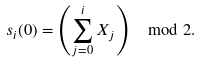Convert formula to latex. <formula><loc_0><loc_0><loc_500><loc_500>s _ { i } ( 0 ) = \left ( \sum _ { j = 0 } ^ { i } X _ { j } \right ) \mod 2 .</formula> 